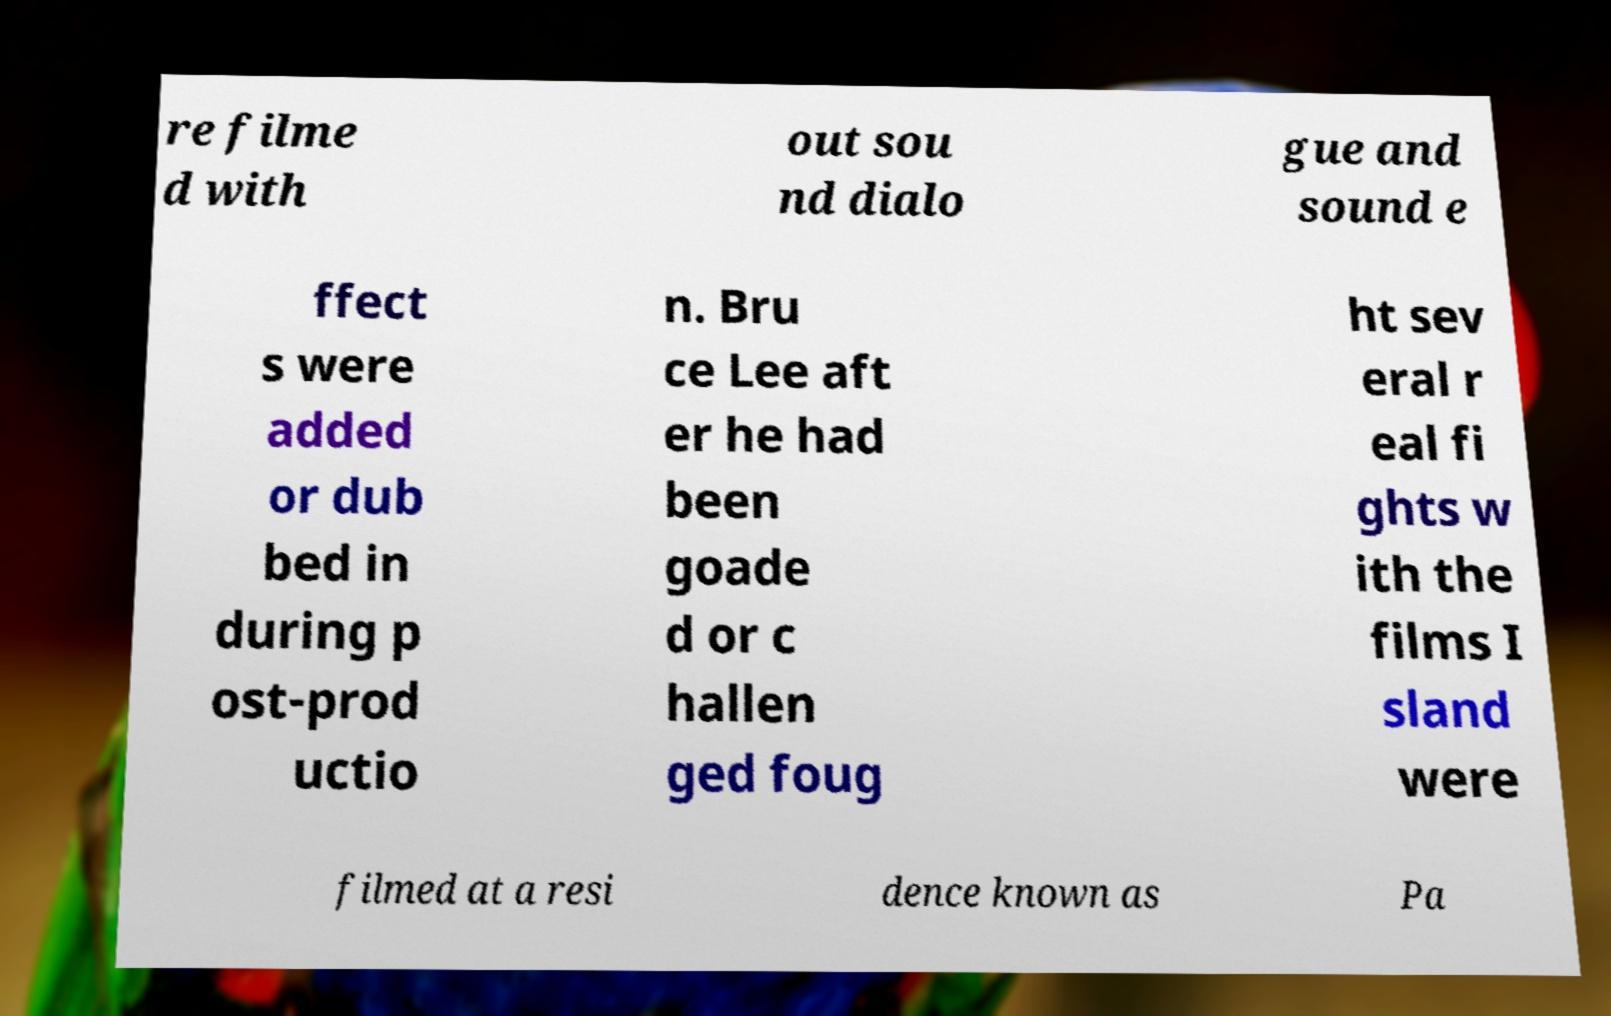I need the written content from this picture converted into text. Can you do that? re filme d with out sou nd dialo gue and sound e ffect s were added or dub bed in during p ost-prod uctio n. Bru ce Lee aft er he had been goade d or c hallen ged foug ht sev eral r eal fi ghts w ith the films I sland were filmed at a resi dence known as Pa 